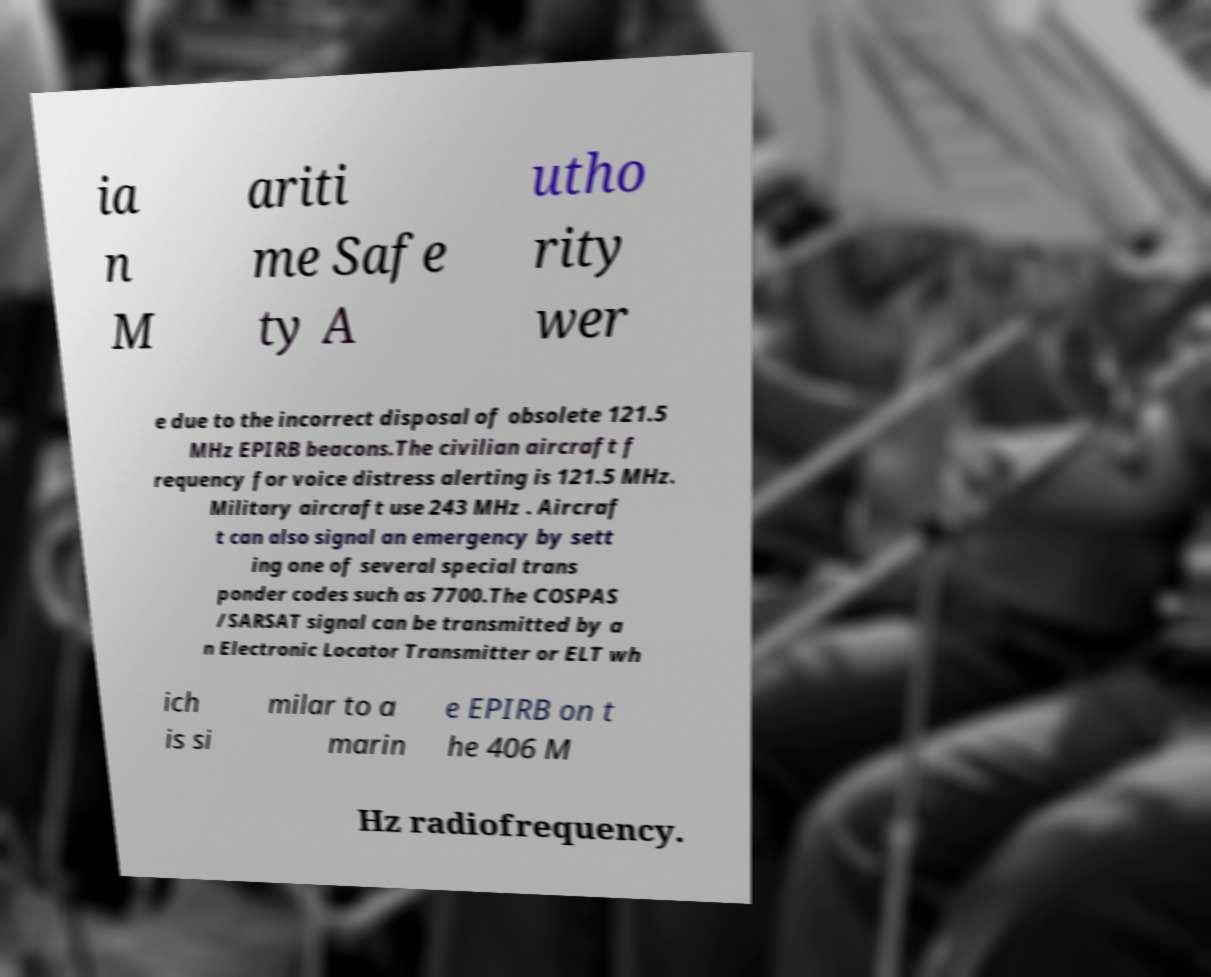Please identify and transcribe the text found in this image. ia n M ariti me Safe ty A utho rity wer e due to the incorrect disposal of obsolete 121.5 MHz EPIRB beacons.The civilian aircraft f requency for voice distress alerting is 121.5 MHz. Military aircraft use 243 MHz . Aircraf t can also signal an emergency by sett ing one of several special trans ponder codes such as 7700.The COSPAS /SARSAT signal can be transmitted by a n Electronic Locator Transmitter or ELT wh ich is si milar to a marin e EPIRB on t he 406 M Hz radiofrequency. 